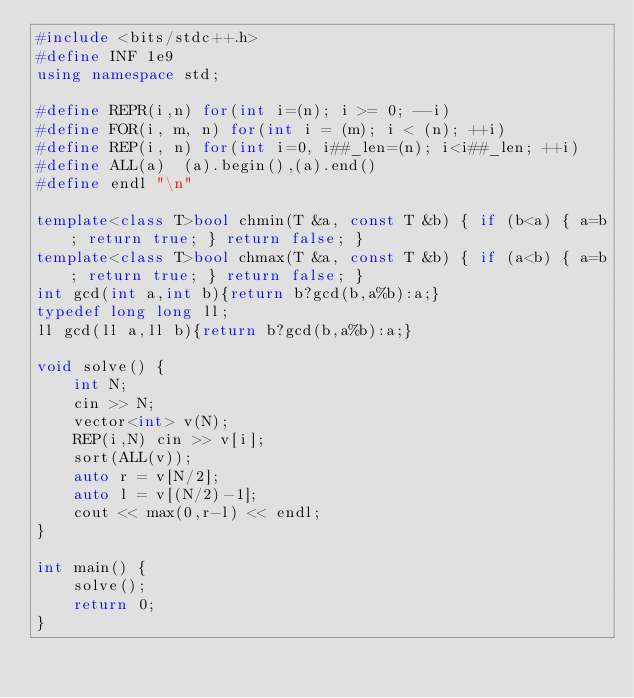<code> <loc_0><loc_0><loc_500><loc_500><_C++_>#include <bits/stdc++.h>
#define INF 1e9
using namespace std;

#define REPR(i,n) for(int i=(n); i >= 0; --i)
#define FOR(i, m, n) for(int i = (m); i < (n); ++i)
#define REP(i, n) for(int i=0, i##_len=(n); i<i##_len; ++i)
#define ALL(a)  (a).begin(),(a).end()
#define endl "\n"

template<class T>bool chmin(T &a, const T &b) { if (b<a) { a=b; return true; } return false; }
template<class T>bool chmax(T &a, const T &b) { if (a<b) { a=b; return true; } return false; }
int gcd(int a,int b){return b?gcd(b,a%b):a;}
typedef long long ll;
ll gcd(ll a,ll b){return b?gcd(b,a%b):a;}

void solve() {
    int N;
    cin >> N;
    vector<int> v(N);
    REP(i,N) cin >> v[i];
    sort(ALL(v));
    auto r = v[N/2];
    auto l = v[(N/2)-1];
    cout << max(0,r-l) << endl;
}

int main() {
    solve();
    return 0;
}
</code> 